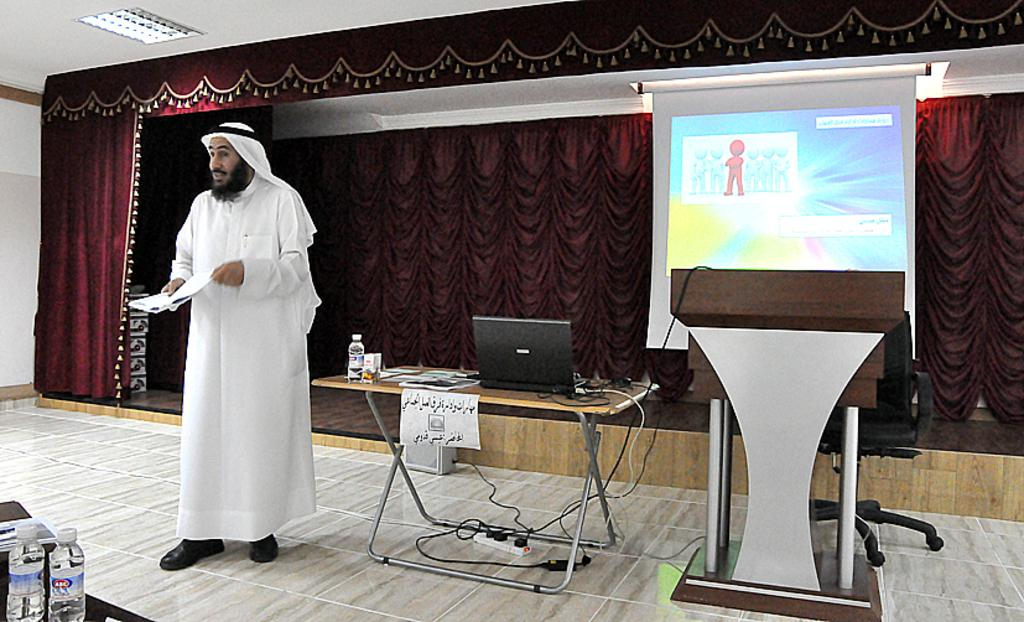What is the person in the image holding? The person is holding a paper. What object is on the table in the image? There is a laptop and a bottle on the table. What can be seen on the table besides the laptop and bottle? There is a screen in the image. What is present behind the person in the image? There is a curtain at the backside of the person. What direction is the hammer pointing in the image? There is no hammer present in the image. How many straws are visible in the image? There are no straws visible in the image. 